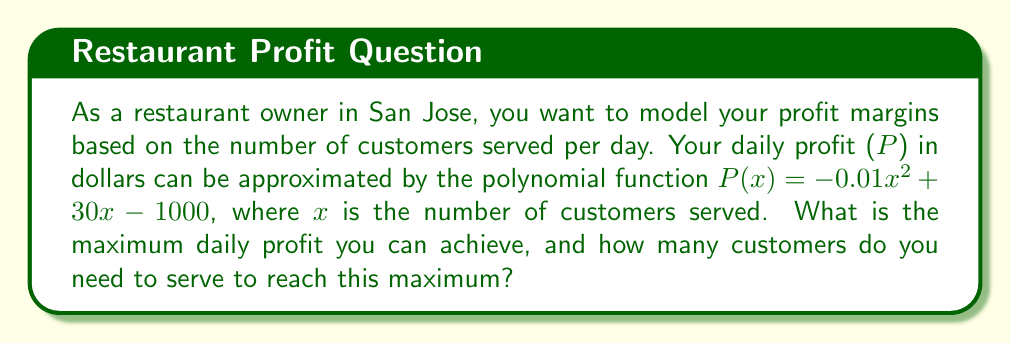Teach me how to tackle this problem. To find the maximum profit and the number of customers needed, we'll follow these steps:

1) The profit function is a quadratic polynomial: $P(x) = -0.01x^2 + 30x - 1000$

2) For a quadratic function in the form $f(x) = ax^2 + bx + c$, the x-coordinate of the vertex represents the value of $x$ that gives the maximum (if $a < 0$) or minimum (if $a > 0$) of the function.

3) The formula for the x-coordinate of the vertex is: $x = -\frac{b}{2a}$

4) In this case, $a = -0.01$, $b = 30$, and $c = -1000$

5) Calculating the x-coordinate:
   $x = -\frac{30}{2(-0.01)} = -\frac{30}{-0.02} = 1500$

6) This means you need to serve 1500 customers to achieve maximum profit.

7) To find the maximum profit, substitute $x = 1500$ into the original function:

   $P(1500) = -0.01(1500)^2 + 30(1500) - 1000$
             $= -0.01(2,250,000) + 45,000 - 1000$
             $= -22,500 + 45,000 - 1000$
             $= 21,500$

Therefore, the maximum daily profit is $21,500.
Answer: Maximum profit: $21,500; Customers needed: 1500 